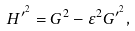Convert formula to latex. <formula><loc_0><loc_0><loc_500><loc_500>H ^ { \prime ^ { 2 } } = G ^ { 2 } - \varepsilon ^ { 2 } G ^ { \prime ^ { 2 } } ,</formula> 